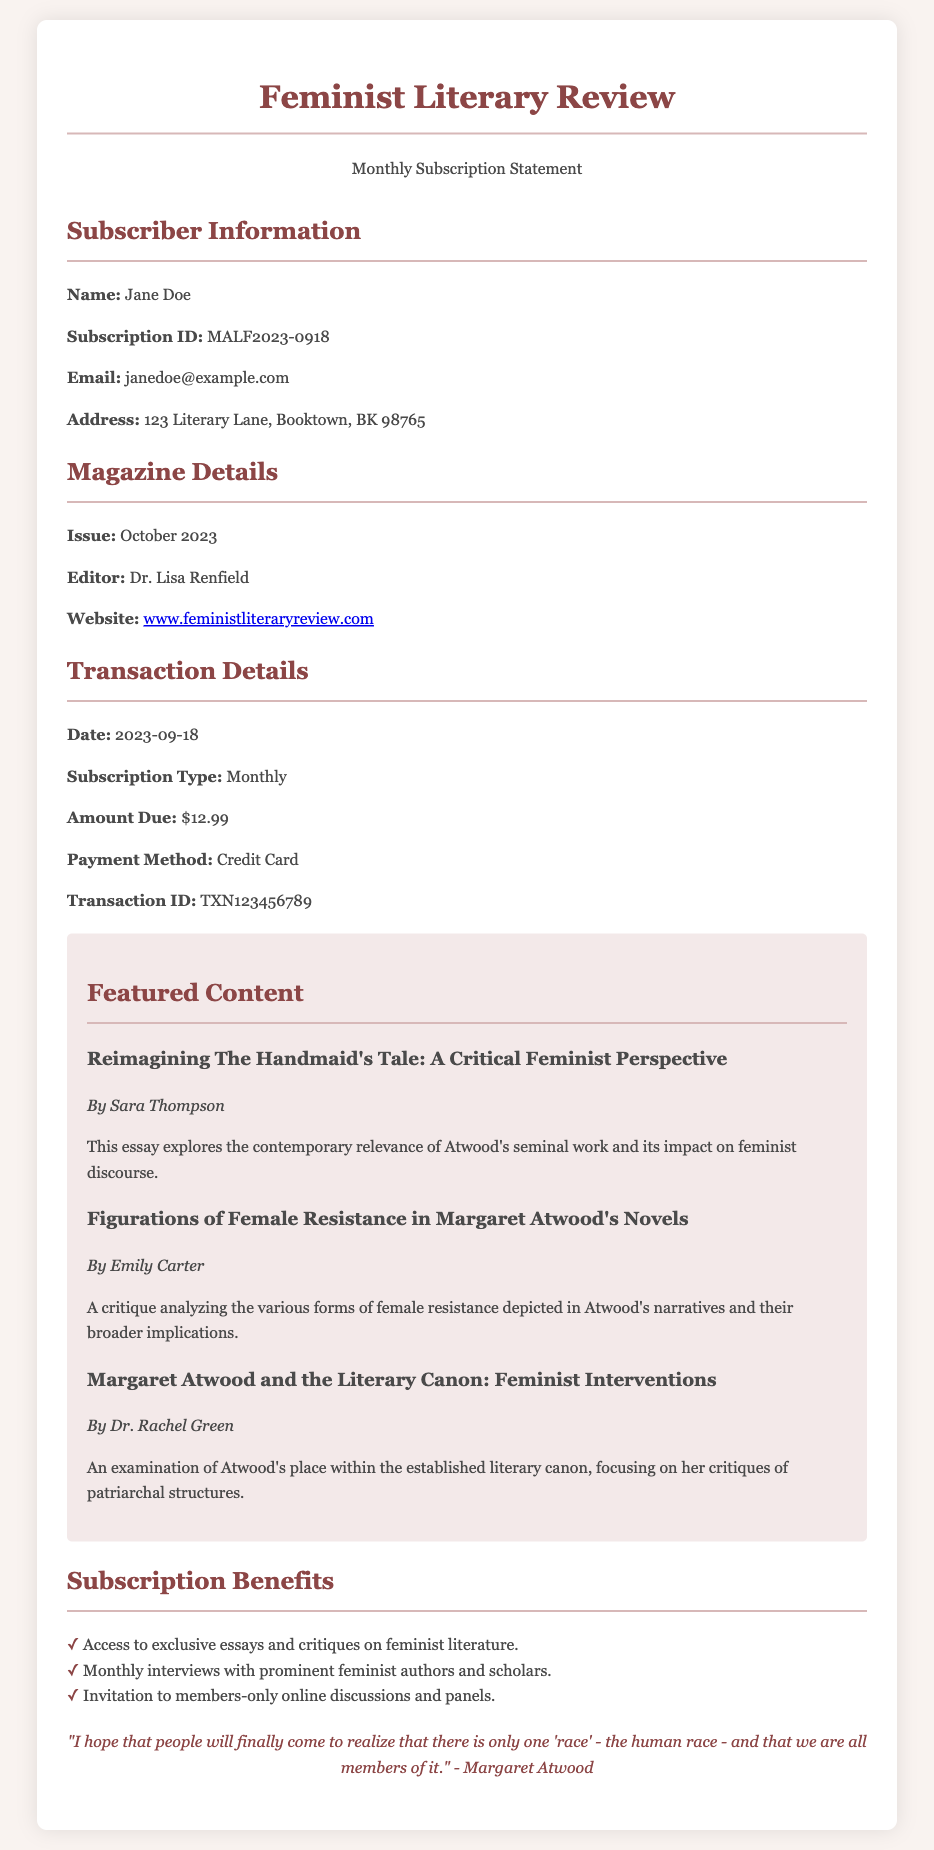What is the subscriber's name? The subscriber's name is explicitly mentioned in the document.
Answer: Jane Doe What is the subscription ID? The subscription ID is a unique identifier listed under subscriber information.
Answer: MALF2023-0918 What is the amount due for the subscription? The amount due is specified in the transaction details section of the document.
Answer: $12.99 Who is the editor of the magazine? The editor's name is provided in the magazine details section.
Answer: Dr. Lisa Renfield What is the issue date of the magazine? The issue date is clearly stated in the magazine details.
Answer: October 2023 What is the payment method used? The payment method is listed in the transaction details.
Answer: Credit Card What is one of the featured content titles? The featured content titles are mentioned in the featured content section.
Answer: Reimagining The Handmaid's Tale: A Critical Feminist Perspective How many subscription benefits are listed? The benefits are enumerated in the subscription benefits section.
Answer: Three What is the website for the magazine? The website is provided under magazine details and is a direct link.
Answer: www.feministliteraryreview.com Who wrote the essay about female resistance in Atwood's novels? The authors of the featured essays are included in the featured content section.
Answer: Emily Carter 